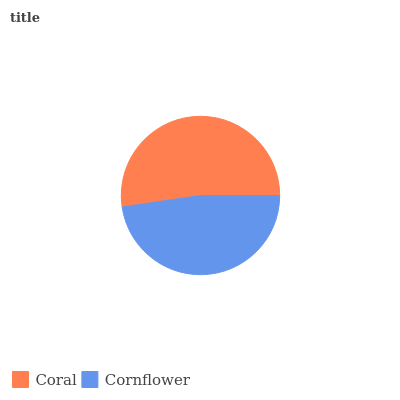Is Cornflower the minimum?
Answer yes or no. Yes. Is Coral the maximum?
Answer yes or no. Yes. Is Cornflower the maximum?
Answer yes or no. No. Is Coral greater than Cornflower?
Answer yes or no. Yes. Is Cornflower less than Coral?
Answer yes or no. Yes. Is Cornflower greater than Coral?
Answer yes or no. No. Is Coral less than Cornflower?
Answer yes or no. No. Is Coral the high median?
Answer yes or no. Yes. Is Cornflower the low median?
Answer yes or no. Yes. Is Cornflower the high median?
Answer yes or no. No. Is Coral the low median?
Answer yes or no. No. 